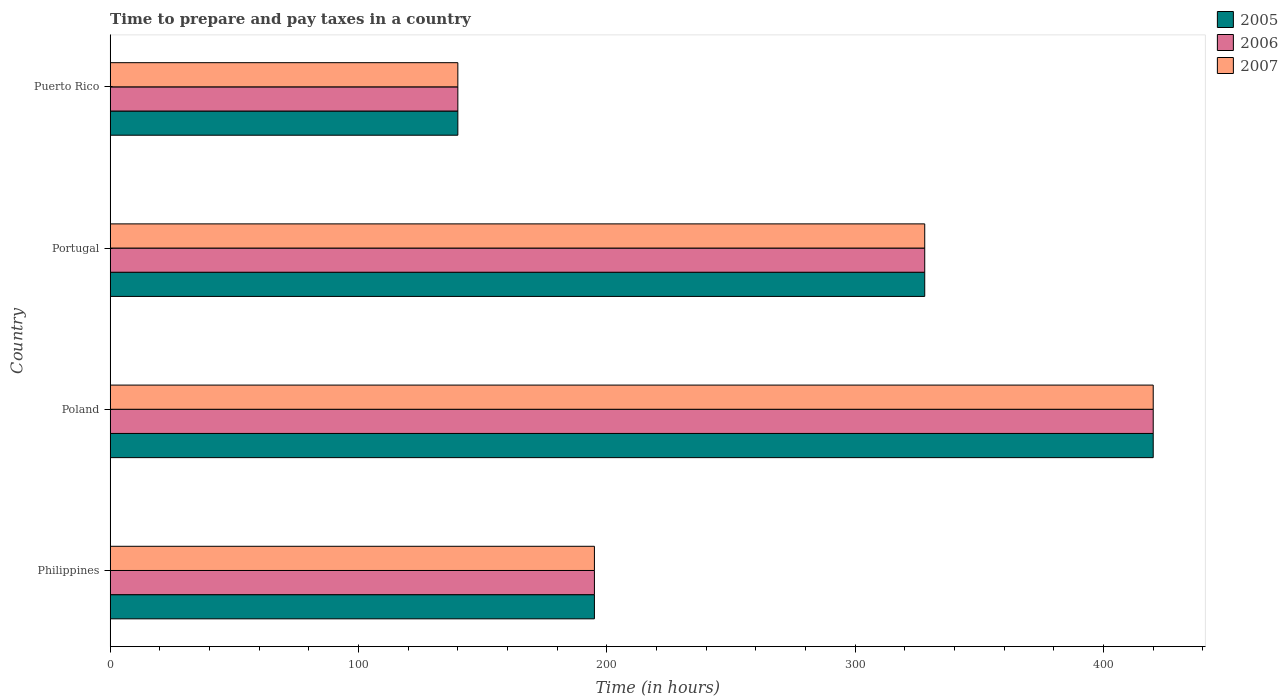How many different coloured bars are there?
Offer a terse response. 3. How many groups of bars are there?
Ensure brevity in your answer.  4. Are the number of bars on each tick of the Y-axis equal?
Offer a very short reply. Yes. How many bars are there on the 2nd tick from the top?
Provide a short and direct response. 3. What is the number of hours required to prepare and pay taxes in 2006 in Portugal?
Make the answer very short. 328. Across all countries, what is the maximum number of hours required to prepare and pay taxes in 2005?
Your response must be concise. 420. Across all countries, what is the minimum number of hours required to prepare and pay taxes in 2007?
Ensure brevity in your answer.  140. In which country was the number of hours required to prepare and pay taxes in 2006 maximum?
Provide a succinct answer. Poland. In which country was the number of hours required to prepare and pay taxes in 2005 minimum?
Offer a terse response. Puerto Rico. What is the total number of hours required to prepare and pay taxes in 2005 in the graph?
Make the answer very short. 1083. What is the difference between the number of hours required to prepare and pay taxes in 2006 in Poland and that in Puerto Rico?
Provide a succinct answer. 280. What is the difference between the number of hours required to prepare and pay taxes in 2005 in Poland and the number of hours required to prepare and pay taxes in 2006 in Puerto Rico?
Your answer should be compact. 280. What is the average number of hours required to prepare and pay taxes in 2006 per country?
Ensure brevity in your answer.  270.75. What is the difference between the number of hours required to prepare and pay taxes in 2005 and number of hours required to prepare and pay taxes in 2007 in Philippines?
Give a very brief answer. 0. In how many countries, is the number of hours required to prepare and pay taxes in 2007 greater than 40 hours?
Keep it short and to the point. 4. What is the ratio of the number of hours required to prepare and pay taxes in 2007 in Portugal to that in Puerto Rico?
Your response must be concise. 2.34. What is the difference between the highest and the second highest number of hours required to prepare and pay taxes in 2007?
Keep it short and to the point. 92. What is the difference between the highest and the lowest number of hours required to prepare and pay taxes in 2006?
Your answer should be very brief. 280. Is the sum of the number of hours required to prepare and pay taxes in 2005 in Philippines and Poland greater than the maximum number of hours required to prepare and pay taxes in 2006 across all countries?
Offer a very short reply. Yes. What does the 2nd bar from the top in Philippines represents?
Your answer should be compact. 2006. What does the 2nd bar from the bottom in Philippines represents?
Provide a short and direct response. 2006. Is it the case that in every country, the sum of the number of hours required to prepare and pay taxes in 2006 and number of hours required to prepare and pay taxes in 2005 is greater than the number of hours required to prepare and pay taxes in 2007?
Your response must be concise. Yes. How many countries are there in the graph?
Give a very brief answer. 4. What is the difference between two consecutive major ticks on the X-axis?
Give a very brief answer. 100. Where does the legend appear in the graph?
Offer a very short reply. Top right. What is the title of the graph?
Your answer should be very brief. Time to prepare and pay taxes in a country. Does "2005" appear as one of the legend labels in the graph?
Your answer should be compact. Yes. What is the label or title of the X-axis?
Provide a short and direct response. Time (in hours). What is the Time (in hours) of 2005 in Philippines?
Make the answer very short. 195. What is the Time (in hours) of 2006 in Philippines?
Offer a very short reply. 195. What is the Time (in hours) of 2007 in Philippines?
Your answer should be very brief. 195. What is the Time (in hours) of 2005 in Poland?
Ensure brevity in your answer.  420. What is the Time (in hours) in 2006 in Poland?
Ensure brevity in your answer.  420. What is the Time (in hours) in 2007 in Poland?
Provide a succinct answer. 420. What is the Time (in hours) of 2005 in Portugal?
Your answer should be compact. 328. What is the Time (in hours) of 2006 in Portugal?
Keep it short and to the point. 328. What is the Time (in hours) of 2007 in Portugal?
Your response must be concise. 328. What is the Time (in hours) in 2005 in Puerto Rico?
Offer a terse response. 140. What is the Time (in hours) of 2006 in Puerto Rico?
Offer a terse response. 140. What is the Time (in hours) of 2007 in Puerto Rico?
Your response must be concise. 140. Across all countries, what is the maximum Time (in hours) of 2005?
Your answer should be very brief. 420. Across all countries, what is the maximum Time (in hours) of 2006?
Your answer should be very brief. 420. Across all countries, what is the maximum Time (in hours) of 2007?
Provide a short and direct response. 420. Across all countries, what is the minimum Time (in hours) of 2005?
Give a very brief answer. 140. Across all countries, what is the minimum Time (in hours) in 2006?
Your answer should be very brief. 140. Across all countries, what is the minimum Time (in hours) of 2007?
Your answer should be very brief. 140. What is the total Time (in hours) in 2005 in the graph?
Ensure brevity in your answer.  1083. What is the total Time (in hours) in 2006 in the graph?
Offer a terse response. 1083. What is the total Time (in hours) in 2007 in the graph?
Your answer should be very brief. 1083. What is the difference between the Time (in hours) in 2005 in Philippines and that in Poland?
Keep it short and to the point. -225. What is the difference between the Time (in hours) of 2006 in Philippines and that in Poland?
Make the answer very short. -225. What is the difference between the Time (in hours) in 2007 in Philippines and that in Poland?
Keep it short and to the point. -225. What is the difference between the Time (in hours) of 2005 in Philippines and that in Portugal?
Offer a terse response. -133. What is the difference between the Time (in hours) in 2006 in Philippines and that in Portugal?
Your response must be concise. -133. What is the difference between the Time (in hours) in 2007 in Philippines and that in Portugal?
Offer a very short reply. -133. What is the difference between the Time (in hours) in 2005 in Philippines and that in Puerto Rico?
Provide a succinct answer. 55. What is the difference between the Time (in hours) in 2007 in Philippines and that in Puerto Rico?
Give a very brief answer. 55. What is the difference between the Time (in hours) in 2005 in Poland and that in Portugal?
Keep it short and to the point. 92. What is the difference between the Time (in hours) of 2006 in Poland and that in Portugal?
Your answer should be very brief. 92. What is the difference between the Time (in hours) of 2007 in Poland and that in Portugal?
Your answer should be compact. 92. What is the difference between the Time (in hours) in 2005 in Poland and that in Puerto Rico?
Your answer should be compact. 280. What is the difference between the Time (in hours) of 2006 in Poland and that in Puerto Rico?
Offer a terse response. 280. What is the difference between the Time (in hours) in 2007 in Poland and that in Puerto Rico?
Keep it short and to the point. 280. What is the difference between the Time (in hours) in 2005 in Portugal and that in Puerto Rico?
Make the answer very short. 188. What is the difference between the Time (in hours) in 2006 in Portugal and that in Puerto Rico?
Make the answer very short. 188. What is the difference between the Time (in hours) in 2007 in Portugal and that in Puerto Rico?
Provide a short and direct response. 188. What is the difference between the Time (in hours) in 2005 in Philippines and the Time (in hours) in 2006 in Poland?
Your answer should be compact. -225. What is the difference between the Time (in hours) of 2005 in Philippines and the Time (in hours) of 2007 in Poland?
Make the answer very short. -225. What is the difference between the Time (in hours) of 2006 in Philippines and the Time (in hours) of 2007 in Poland?
Give a very brief answer. -225. What is the difference between the Time (in hours) of 2005 in Philippines and the Time (in hours) of 2006 in Portugal?
Make the answer very short. -133. What is the difference between the Time (in hours) of 2005 in Philippines and the Time (in hours) of 2007 in Portugal?
Your answer should be compact. -133. What is the difference between the Time (in hours) of 2006 in Philippines and the Time (in hours) of 2007 in Portugal?
Provide a succinct answer. -133. What is the difference between the Time (in hours) of 2005 in Philippines and the Time (in hours) of 2007 in Puerto Rico?
Keep it short and to the point. 55. What is the difference between the Time (in hours) of 2005 in Poland and the Time (in hours) of 2006 in Portugal?
Keep it short and to the point. 92. What is the difference between the Time (in hours) in 2005 in Poland and the Time (in hours) in 2007 in Portugal?
Make the answer very short. 92. What is the difference between the Time (in hours) in 2006 in Poland and the Time (in hours) in 2007 in Portugal?
Your answer should be compact. 92. What is the difference between the Time (in hours) of 2005 in Poland and the Time (in hours) of 2006 in Puerto Rico?
Your response must be concise. 280. What is the difference between the Time (in hours) of 2005 in Poland and the Time (in hours) of 2007 in Puerto Rico?
Make the answer very short. 280. What is the difference between the Time (in hours) of 2006 in Poland and the Time (in hours) of 2007 in Puerto Rico?
Keep it short and to the point. 280. What is the difference between the Time (in hours) in 2005 in Portugal and the Time (in hours) in 2006 in Puerto Rico?
Your answer should be very brief. 188. What is the difference between the Time (in hours) in 2005 in Portugal and the Time (in hours) in 2007 in Puerto Rico?
Your answer should be compact. 188. What is the difference between the Time (in hours) in 2006 in Portugal and the Time (in hours) in 2007 in Puerto Rico?
Give a very brief answer. 188. What is the average Time (in hours) of 2005 per country?
Give a very brief answer. 270.75. What is the average Time (in hours) of 2006 per country?
Your response must be concise. 270.75. What is the average Time (in hours) of 2007 per country?
Ensure brevity in your answer.  270.75. What is the difference between the Time (in hours) of 2005 and Time (in hours) of 2006 in Portugal?
Make the answer very short. 0. What is the difference between the Time (in hours) in 2005 and Time (in hours) in 2006 in Puerto Rico?
Provide a short and direct response. 0. What is the difference between the Time (in hours) of 2005 and Time (in hours) of 2007 in Puerto Rico?
Provide a short and direct response. 0. What is the ratio of the Time (in hours) of 2005 in Philippines to that in Poland?
Your answer should be very brief. 0.46. What is the ratio of the Time (in hours) of 2006 in Philippines to that in Poland?
Provide a short and direct response. 0.46. What is the ratio of the Time (in hours) of 2007 in Philippines to that in Poland?
Ensure brevity in your answer.  0.46. What is the ratio of the Time (in hours) of 2005 in Philippines to that in Portugal?
Provide a short and direct response. 0.59. What is the ratio of the Time (in hours) in 2006 in Philippines to that in Portugal?
Make the answer very short. 0.59. What is the ratio of the Time (in hours) of 2007 in Philippines to that in Portugal?
Keep it short and to the point. 0.59. What is the ratio of the Time (in hours) in 2005 in Philippines to that in Puerto Rico?
Your answer should be very brief. 1.39. What is the ratio of the Time (in hours) in 2006 in Philippines to that in Puerto Rico?
Offer a very short reply. 1.39. What is the ratio of the Time (in hours) in 2007 in Philippines to that in Puerto Rico?
Give a very brief answer. 1.39. What is the ratio of the Time (in hours) in 2005 in Poland to that in Portugal?
Provide a short and direct response. 1.28. What is the ratio of the Time (in hours) of 2006 in Poland to that in Portugal?
Offer a very short reply. 1.28. What is the ratio of the Time (in hours) of 2007 in Poland to that in Portugal?
Your answer should be compact. 1.28. What is the ratio of the Time (in hours) in 2007 in Poland to that in Puerto Rico?
Make the answer very short. 3. What is the ratio of the Time (in hours) in 2005 in Portugal to that in Puerto Rico?
Ensure brevity in your answer.  2.34. What is the ratio of the Time (in hours) of 2006 in Portugal to that in Puerto Rico?
Provide a short and direct response. 2.34. What is the ratio of the Time (in hours) in 2007 in Portugal to that in Puerto Rico?
Your response must be concise. 2.34. What is the difference between the highest and the second highest Time (in hours) of 2005?
Your answer should be compact. 92. What is the difference between the highest and the second highest Time (in hours) of 2006?
Your answer should be compact. 92. What is the difference between the highest and the second highest Time (in hours) in 2007?
Provide a short and direct response. 92. What is the difference between the highest and the lowest Time (in hours) of 2005?
Make the answer very short. 280. What is the difference between the highest and the lowest Time (in hours) of 2006?
Offer a terse response. 280. What is the difference between the highest and the lowest Time (in hours) of 2007?
Make the answer very short. 280. 